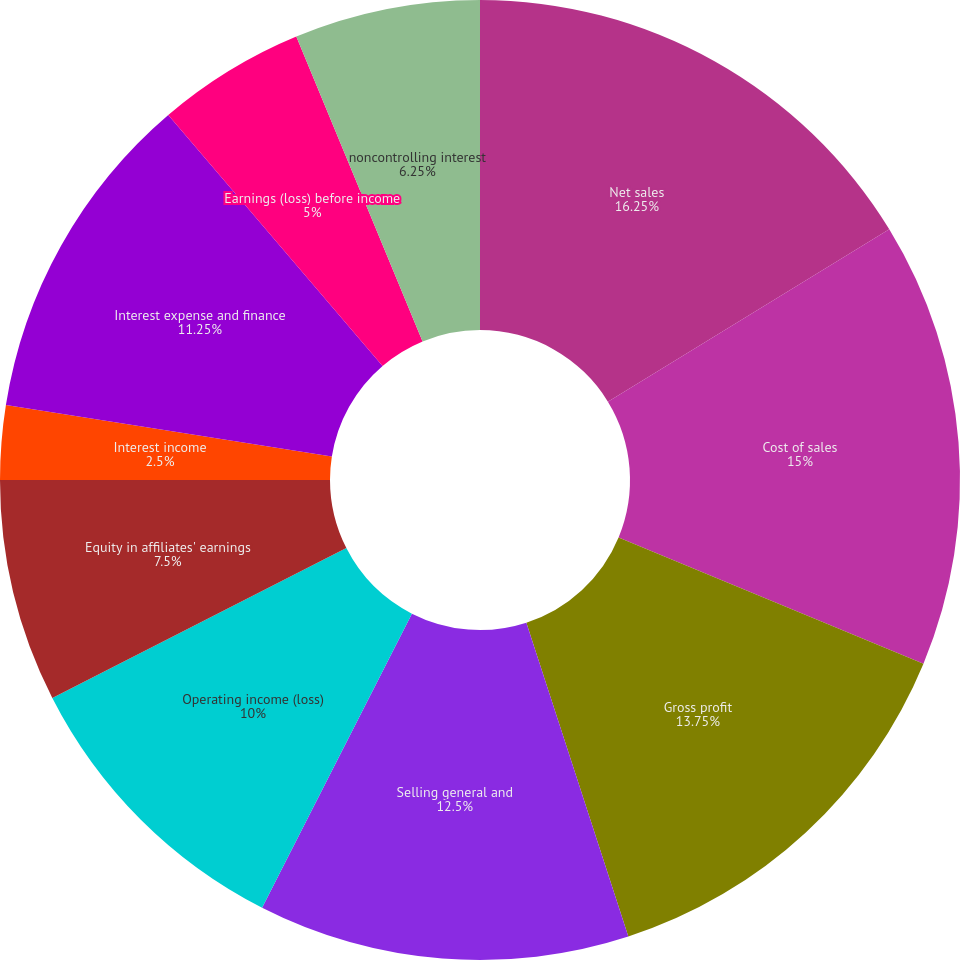Convert chart. <chart><loc_0><loc_0><loc_500><loc_500><pie_chart><fcel>Net sales<fcel>Cost of sales<fcel>Gross profit<fcel>Selling general and<fcel>Operating income (loss)<fcel>Equity in affiliates' earnings<fcel>Interest income<fcel>Interest expense and finance<fcel>Earnings (loss) before income<fcel>noncontrolling interest<nl><fcel>16.25%<fcel>15.0%<fcel>13.75%<fcel>12.5%<fcel>10.0%<fcel>7.5%<fcel>2.5%<fcel>11.25%<fcel>5.0%<fcel>6.25%<nl></chart> 